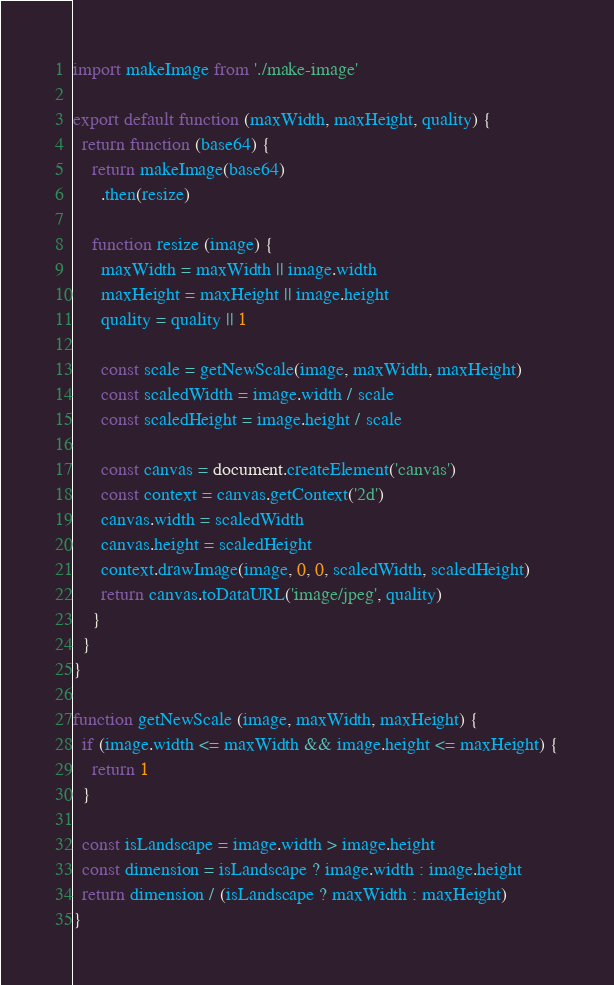<code> <loc_0><loc_0><loc_500><loc_500><_JavaScript_>import makeImage from './make-image'

export default function (maxWidth, maxHeight, quality) {
  return function (base64) {
    return makeImage(base64)
      .then(resize)

    function resize (image) {
      maxWidth = maxWidth || image.width
      maxHeight = maxHeight || image.height
      quality = quality || 1

      const scale = getNewScale(image, maxWidth, maxHeight)
      const scaledWidth = image.width / scale
      const scaledHeight = image.height / scale

      const canvas = document.createElement('canvas')
      const context = canvas.getContext('2d')
      canvas.width = scaledWidth
      canvas.height = scaledHeight
      context.drawImage(image, 0, 0, scaledWidth, scaledHeight)
      return canvas.toDataURL('image/jpeg', quality)
    }
  }
}

function getNewScale (image, maxWidth, maxHeight) {
  if (image.width <= maxWidth && image.height <= maxHeight) {
    return 1
  }

  const isLandscape = image.width > image.height
  const dimension = isLandscape ? image.width : image.height
  return dimension / (isLandscape ? maxWidth : maxHeight)
}
</code> 